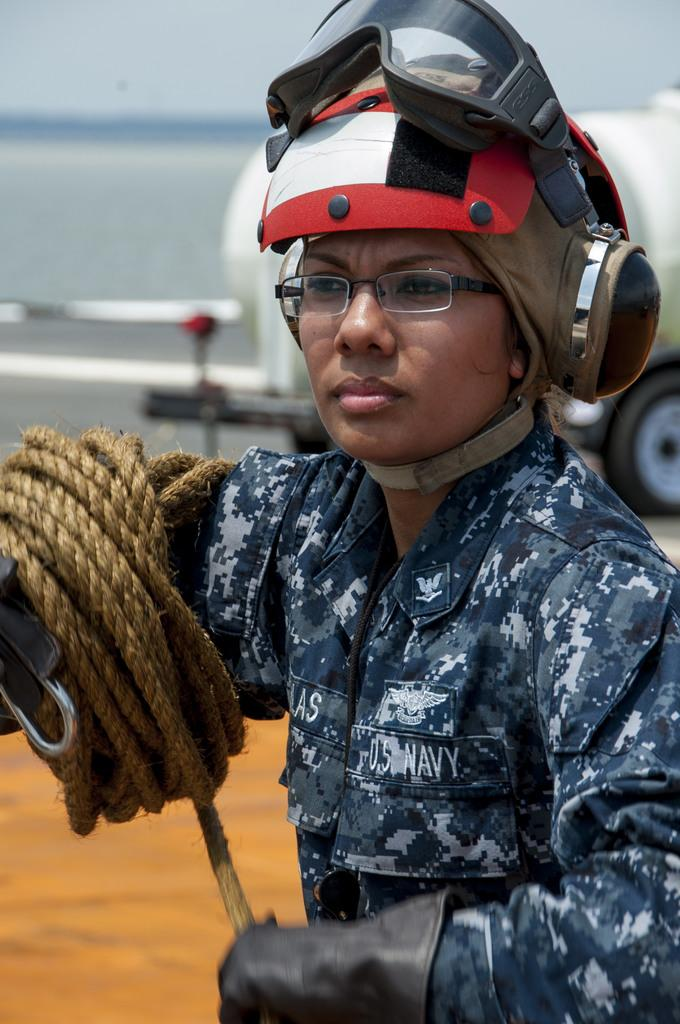Who is present in the image? There is a woman in the image. What is the woman wearing? The woman is wearing a uniform and a helmet. What is the woman holding in the image? The woman is holding a rope. What can be seen in the background of the image? There is a vehicle visible in the background of the image. Where is the vehicle located in the image? The vehicle is on the road. What type of chess piece is the woman playing with in the image? There is no chess piece present in the image. Is the woman performing on a stage in the image? There is no stage present in the image. 